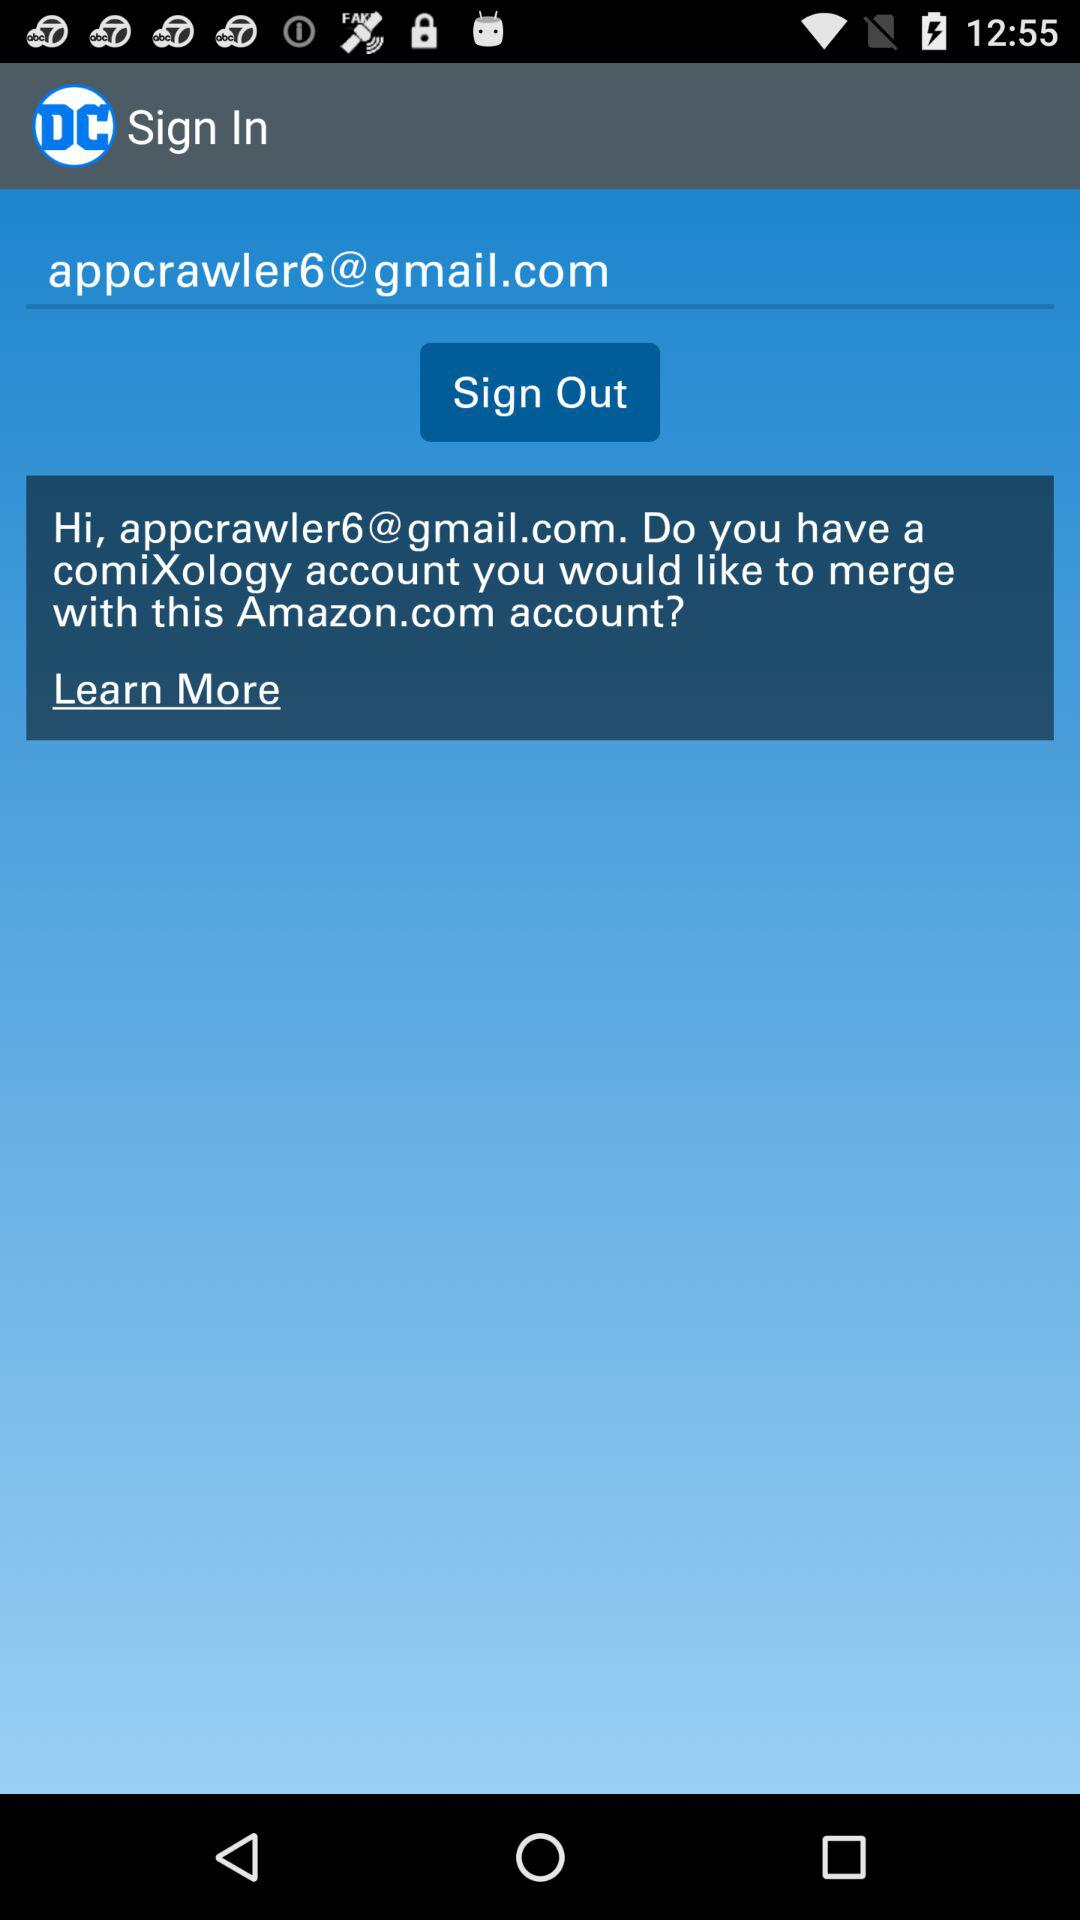What is the email address? The email address is appcrawler6@gmail.com. 